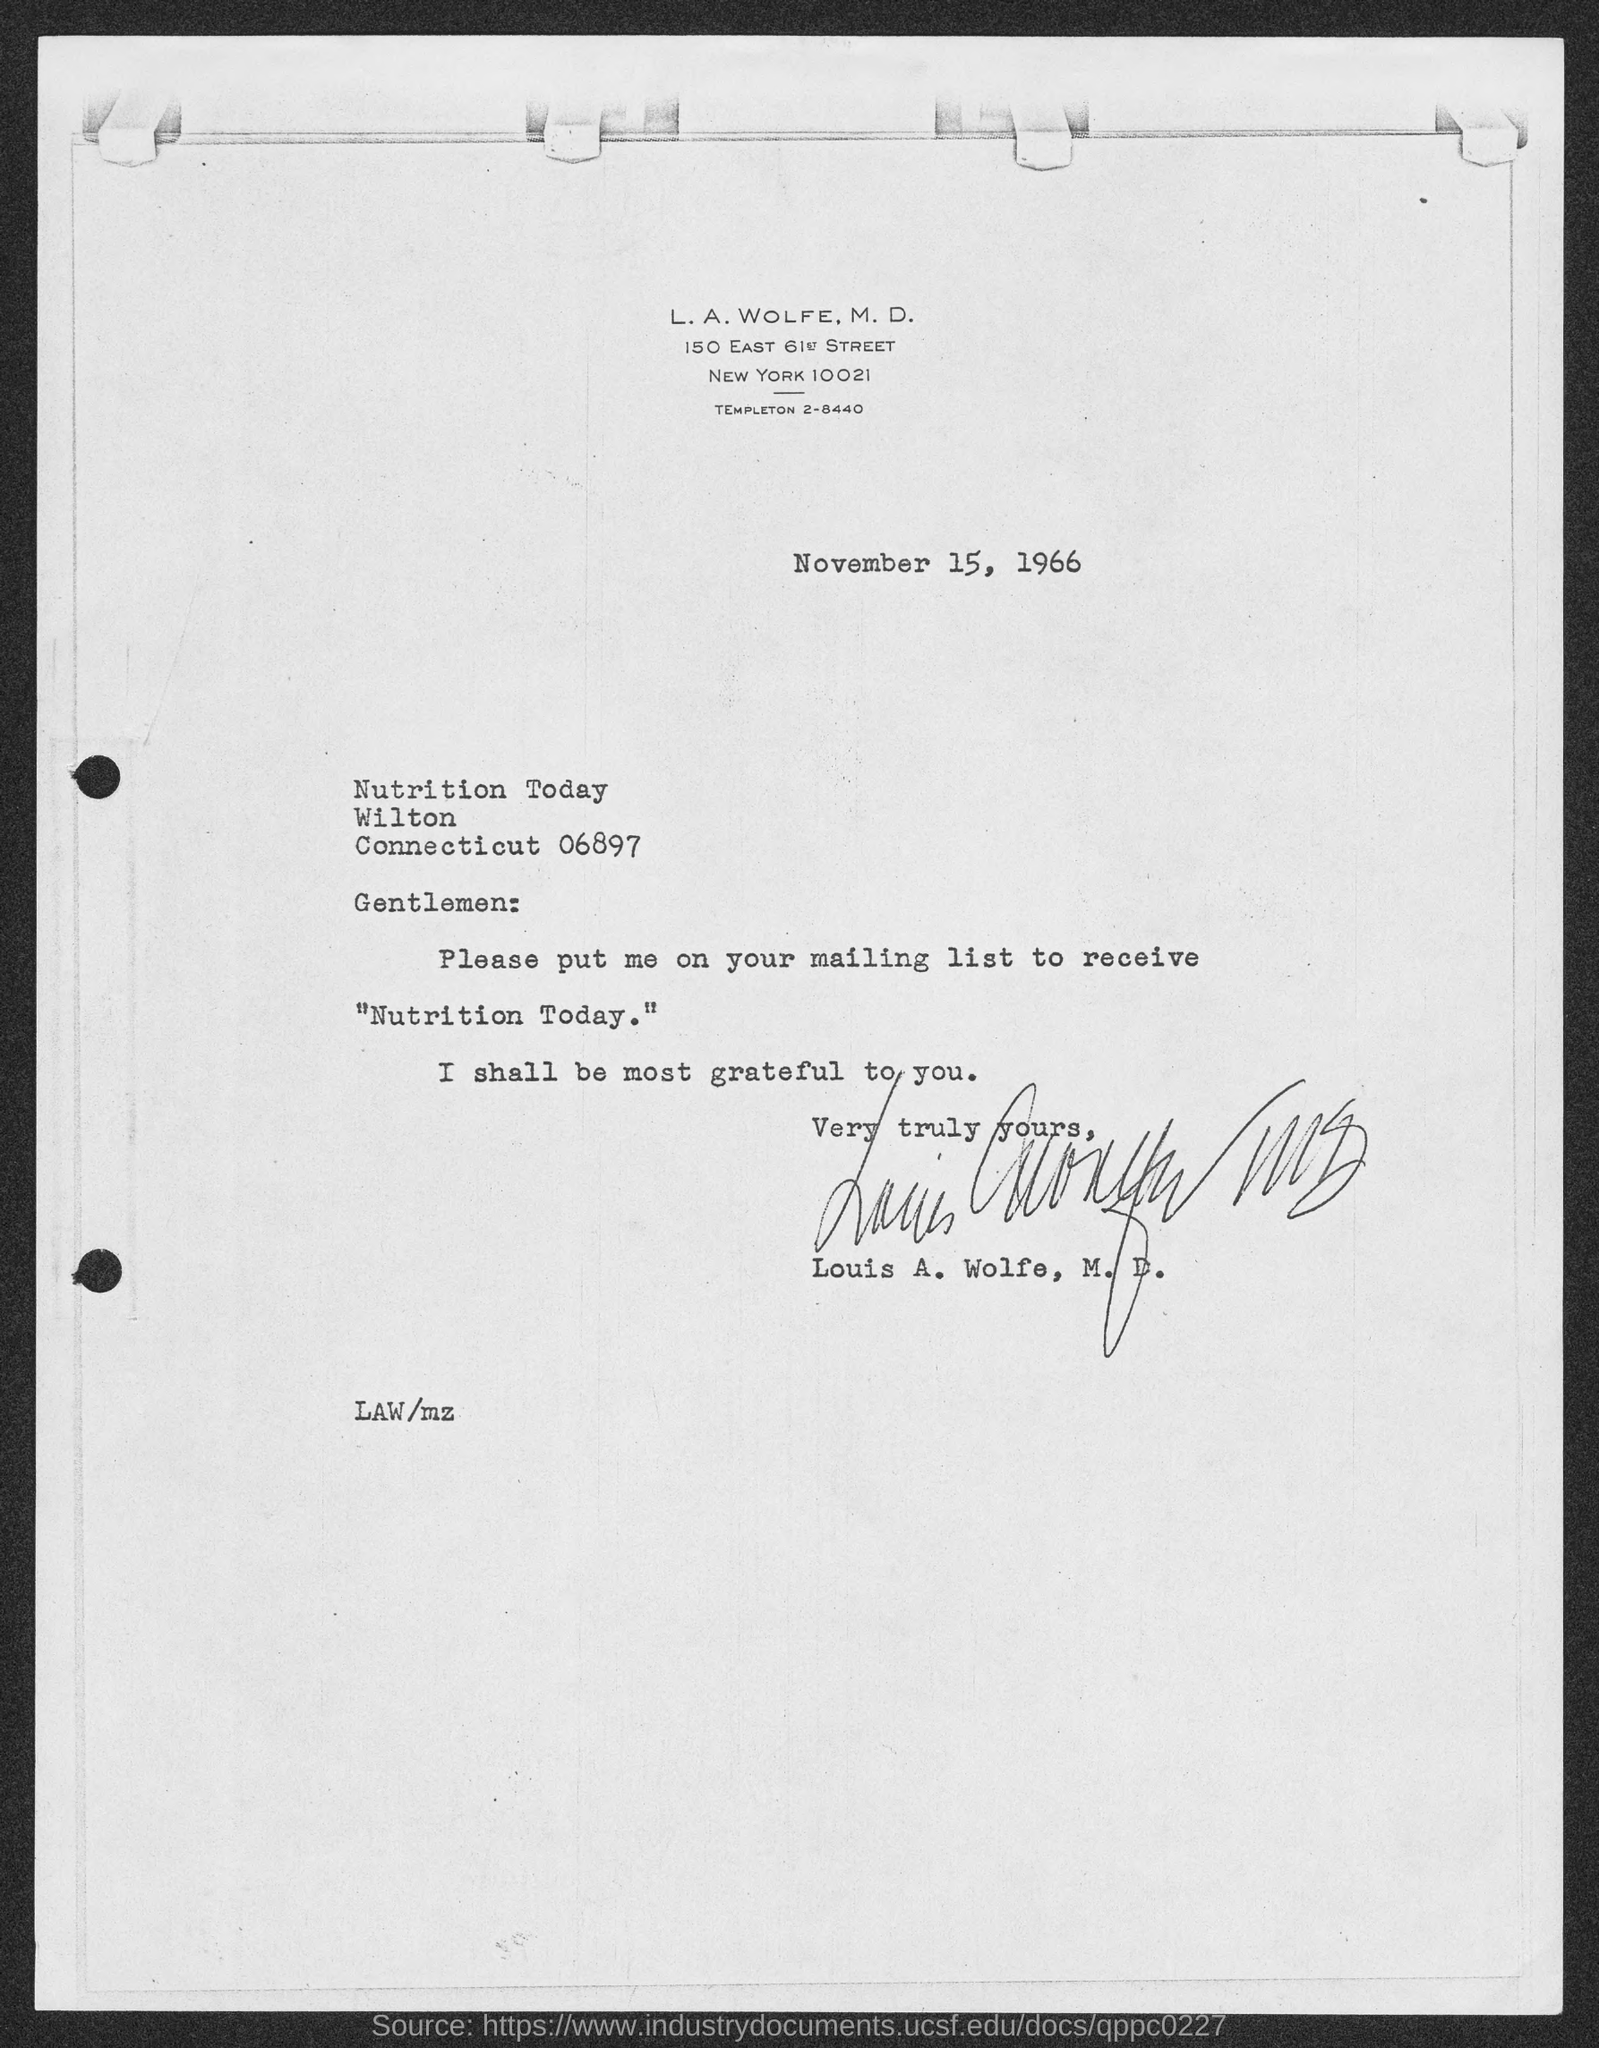What is the date mentioned in this letter?
Give a very brief answer. November 15, 1966. 